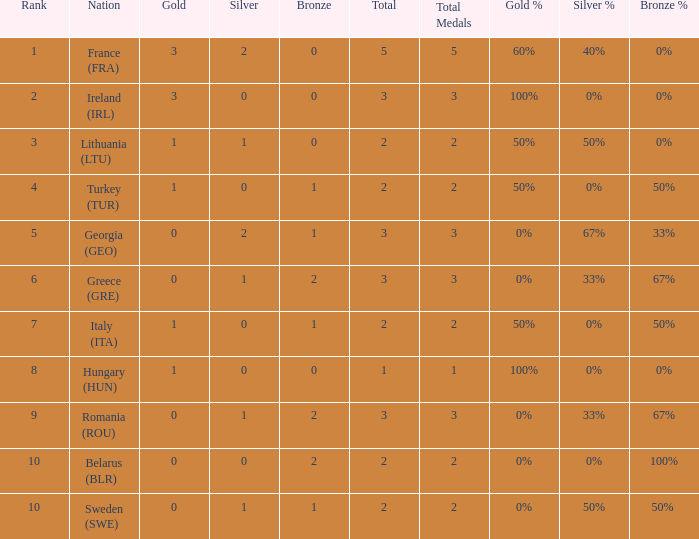What's the total of Sweden (SWE) having less than 1 silver? None. 